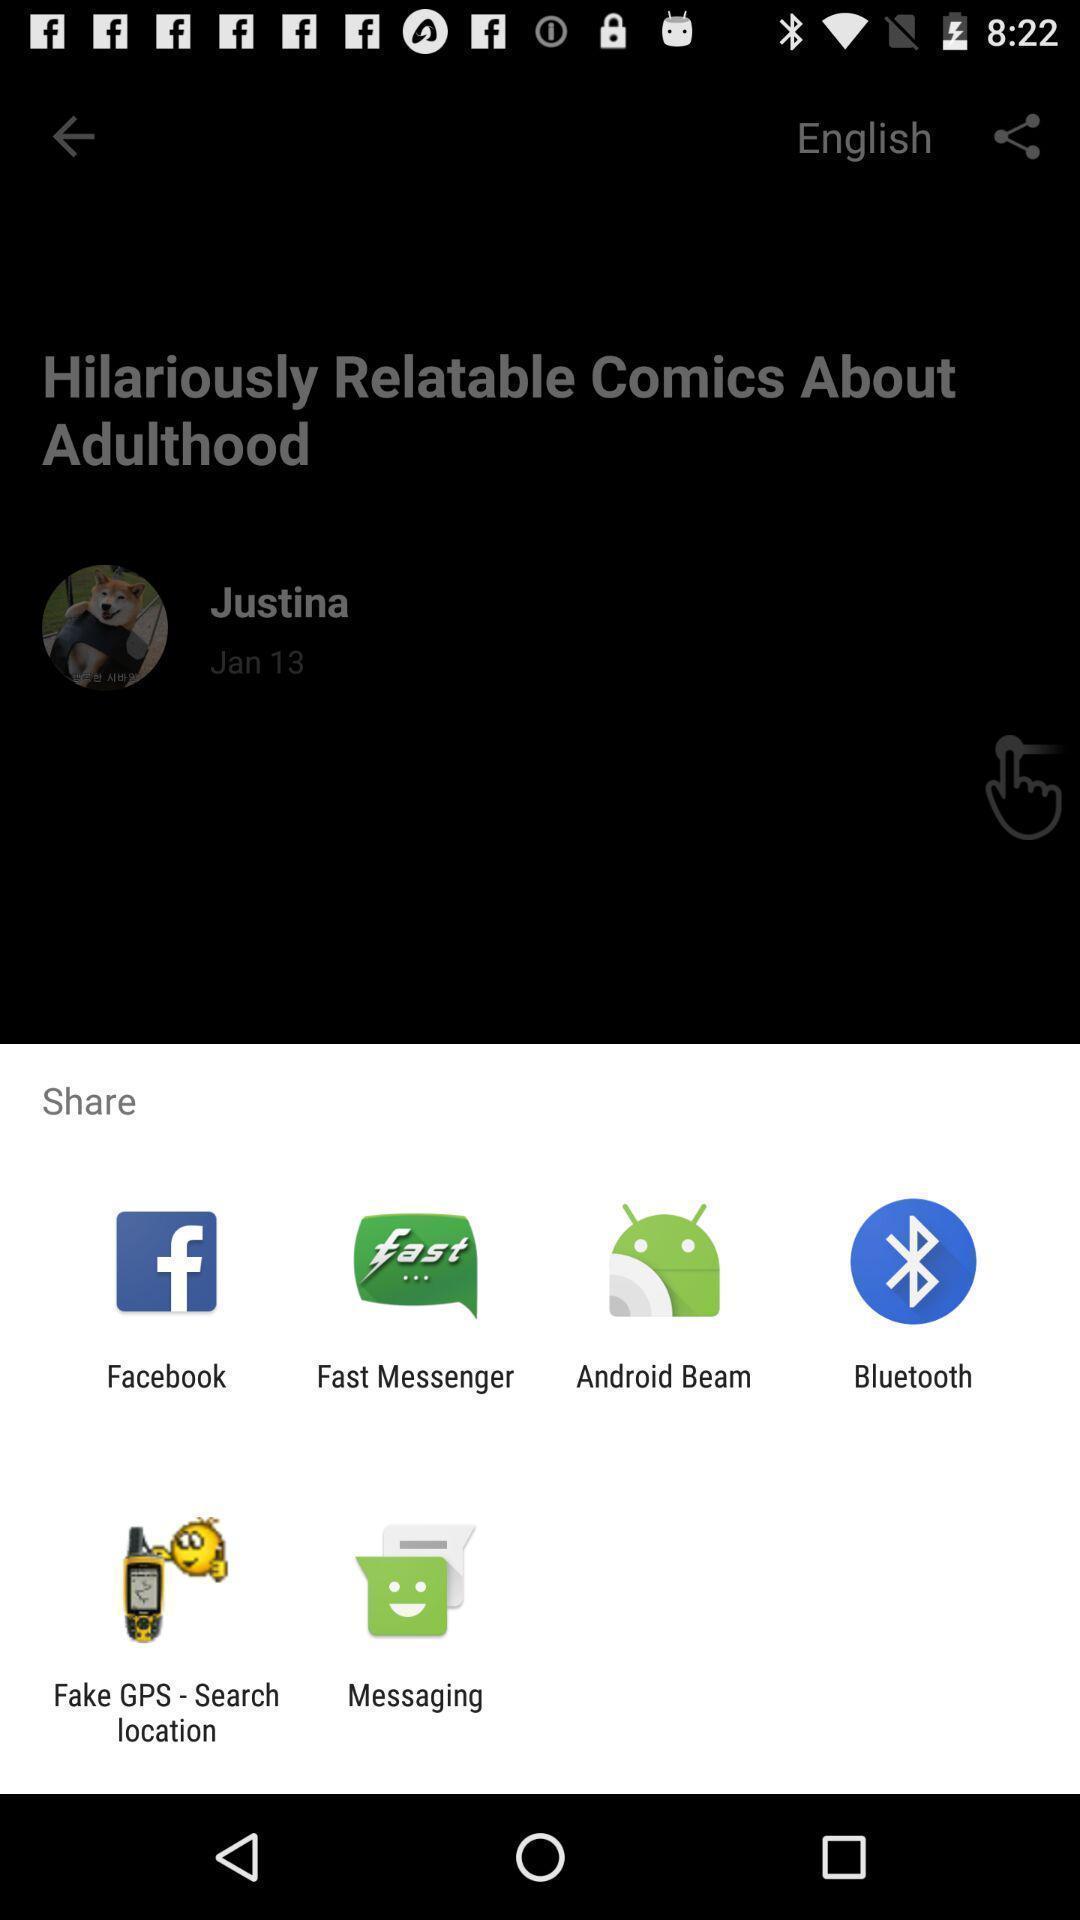Provide a description of this screenshot. Share options page of a languagetranslator app. 